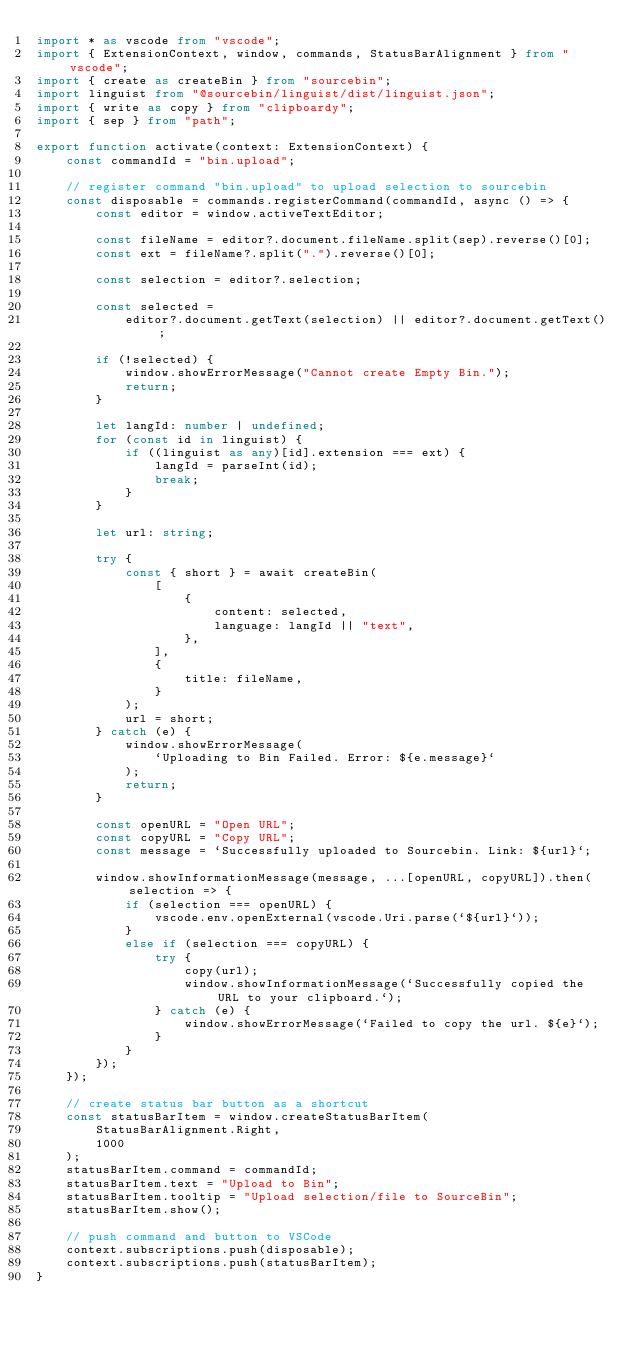<code> <loc_0><loc_0><loc_500><loc_500><_TypeScript_>import * as vscode from "vscode";
import { ExtensionContext, window, commands, StatusBarAlignment } from "vscode";
import { create as createBin } from "sourcebin";
import linguist from "@sourcebin/linguist/dist/linguist.json";
import { write as copy } from "clipboardy";
import { sep } from "path";

export function activate(context: ExtensionContext) {
    const commandId = "bin.upload";

    // register command "bin.upload" to upload selection to sourcebin
    const disposable = commands.registerCommand(commandId, async () => {
        const editor = window.activeTextEditor;

        const fileName = editor?.document.fileName.split(sep).reverse()[0];
        const ext = fileName?.split(".").reverse()[0];

        const selection = editor?.selection;

        const selected =
            editor?.document.getText(selection) || editor?.document.getText();

        if (!selected) {
            window.showErrorMessage("Cannot create Empty Bin.");
            return;
        }

        let langId: number | undefined;
        for (const id in linguist) {
            if ((linguist as any)[id].extension === ext) {
                langId = parseInt(id);
                break;
            }
        }

        let url: string;

        try {
            const { short } = await createBin(
                [
                    {
                        content: selected,
                        language: langId || "text",
                    },
                ],
                {
                    title: fileName,
                }
            );
            url = short;
        } catch (e) {
            window.showErrorMessage(
                `Uploading to Bin Failed. Error: ${e.message}`
            );
            return;
        }

        const openURL = "Open URL";
        const copyURL = "Copy URL";
        const message = `Successfully uploaded to Sourcebin. Link: ${url}`;

        window.showInformationMessage(message, ...[openURL, copyURL]).then(selection => {
            if (selection === openURL) {
                vscode.env.openExternal(vscode.Uri.parse(`${url}`));
            }
            else if (selection === copyURL) {
                try {
                    copy(url);
                    window.showInformationMessage(`Successfully copied the URL to your clipboard.`);
                } catch (e) {
                    window.showErrorMessage(`Failed to copy the url. ${e}`);
                }
            }
        });
    });

    // create status bar button as a shortcut
    const statusBarItem = window.createStatusBarItem(
        StatusBarAlignment.Right,
        1000
    );
    statusBarItem.command = commandId;
    statusBarItem.text = "Upload to Bin";
    statusBarItem.tooltip = "Upload selection/file to SourceBin";
    statusBarItem.show();

    // push command and button to VSCode
    context.subscriptions.push(disposable);
    context.subscriptions.push(statusBarItem);
}
</code> 